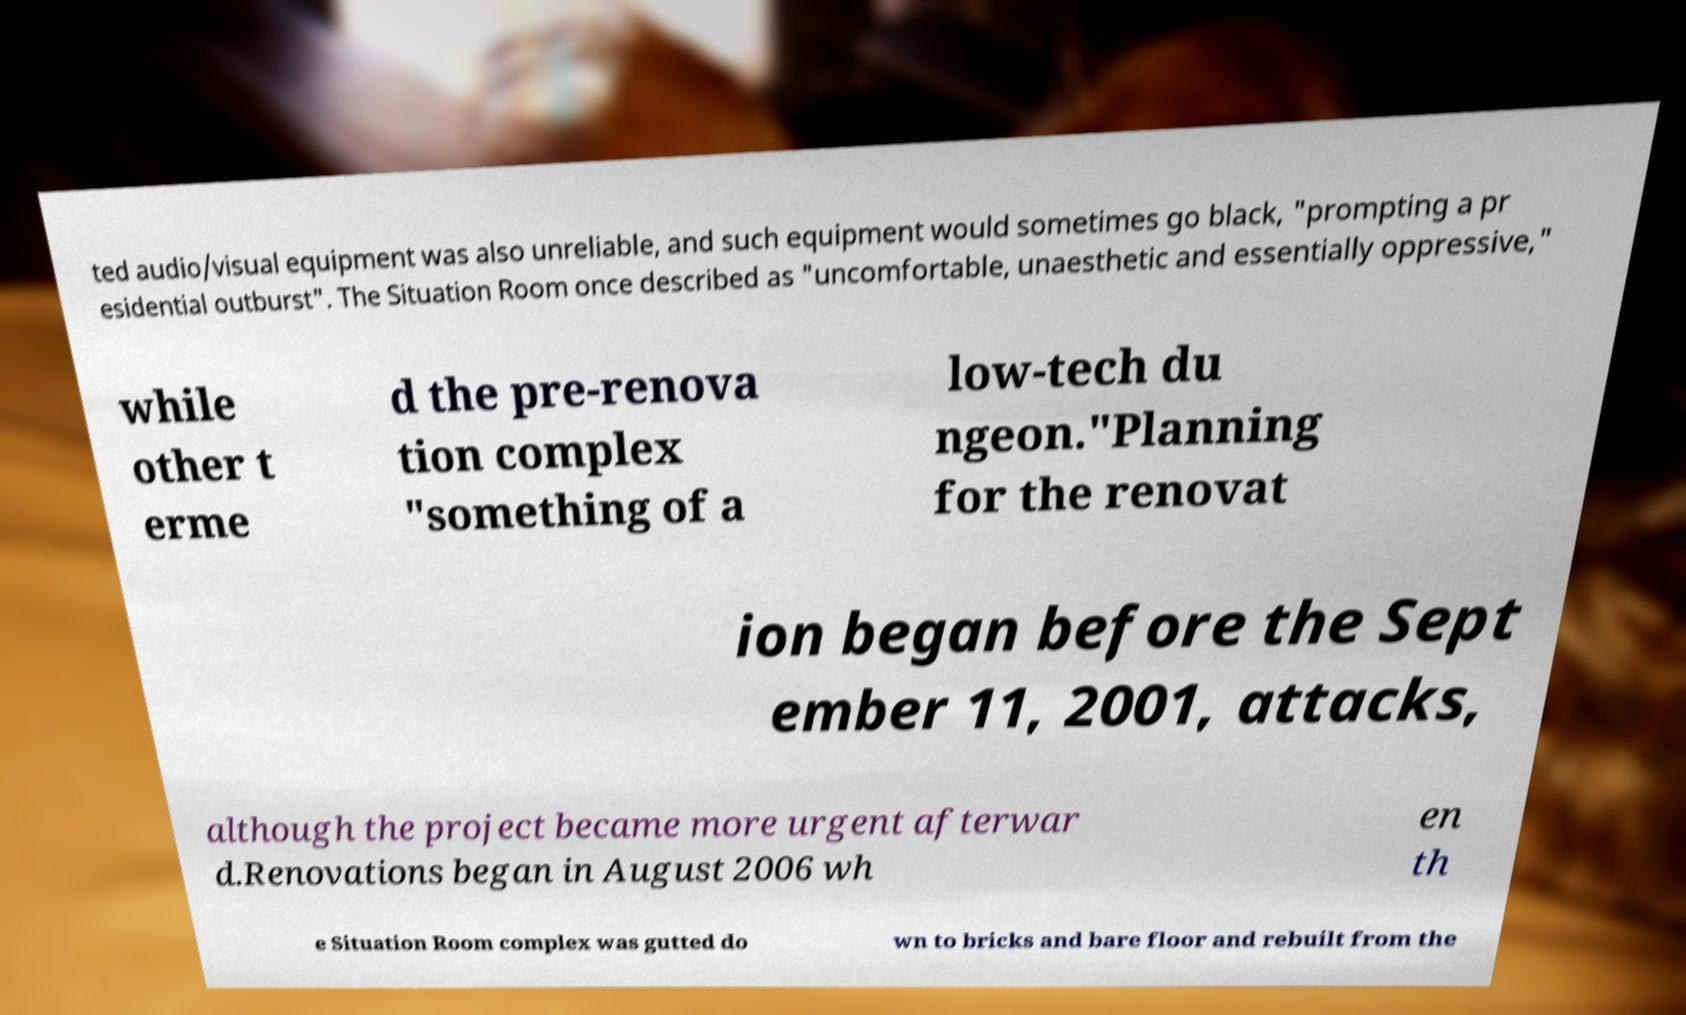Could you assist in decoding the text presented in this image and type it out clearly? ted audio/visual equipment was also unreliable, and such equipment would sometimes go black, "prompting a pr esidential outburst". The Situation Room once described as "uncomfortable, unaesthetic and essentially oppressive," while other t erme d the pre-renova tion complex "something of a low-tech du ngeon."Planning for the renovat ion began before the Sept ember 11, 2001, attacks, although the project became more urgent afterwar d.Renovations began in August 2006 wh en th e Situation Room complex was gutted do wn to bricks and bare floor and rebuilt from the 